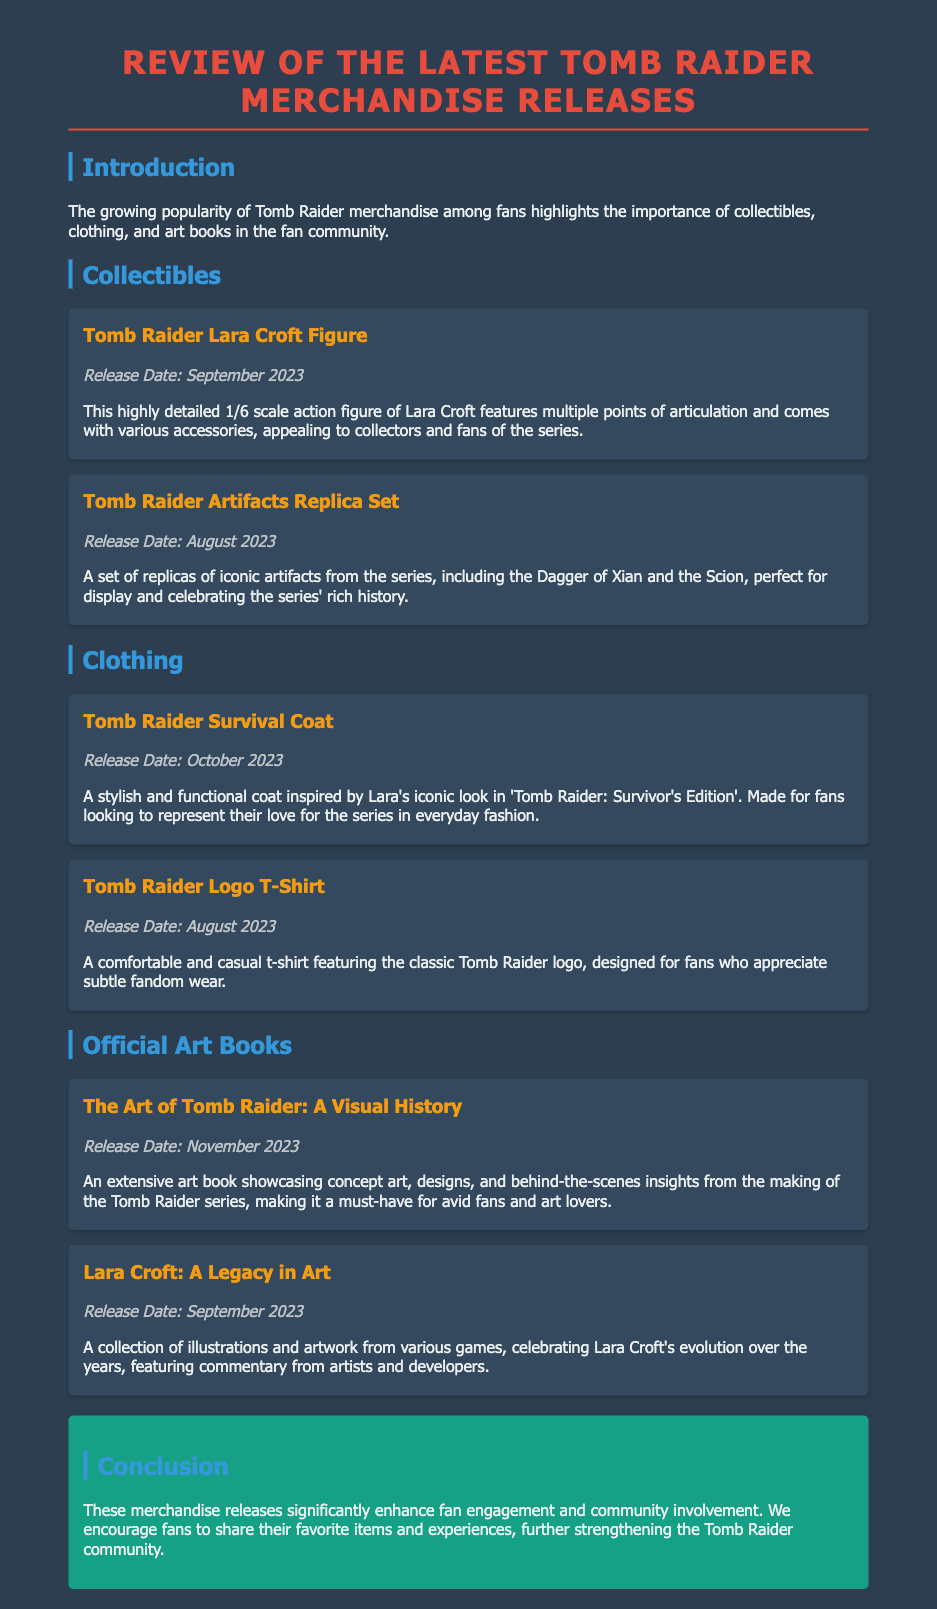What is the title of the latest Tomb Raider merchandise review? The title of the document is mentioned prominently at the top as "Review of the Latest Tomb Raider Merchandise Releases."
Answer: Review of the Latest Tomb Raider Merchandise Releases When was the Tomb Raider Survival Coat released? The release date for the Tomb Raider Survival Coat is specified in the document as October 2023.
Answer: October 2023 What kind of figure is included in the collectibles section? The document describes a "1/6 scale action figure of Lara Croft" in the collectibles section.
Answer: 1/6 scale action figure of Lara Croft Which official art book is released in November 2023? The document clearly states the title of the art book being released in November 2023 as "The Art of Tomb Raider: A Visual History."
Answer: The Art of Tomb Raider: A Visual History What item represents Lara Croft's evolution over the years? The document mentions "Lara Croft: A Legacy in Art" as a collection celebrating Lara Croft's evolution.
Answer: Lara Croft: A Legacy in Art What is the release date for the Tomb Raider Logo T-Shirt? The release date for the Tomb Raider Logo T-Shirt is given as August 2023 in the document.
Answer: August 2023 Why are the merchandise releases important for fans? The document discusses how merchandise releases enhance fan engagement and community involvement.
Answer: Enhance fan engagement and community involvement What is the primary function of the Tomb Raider Artifacts Replica Set? The document states that the set is "perfect for display and celebrating the series' rich history."
Answer: Perfect for display and celebrating the series' rich history 